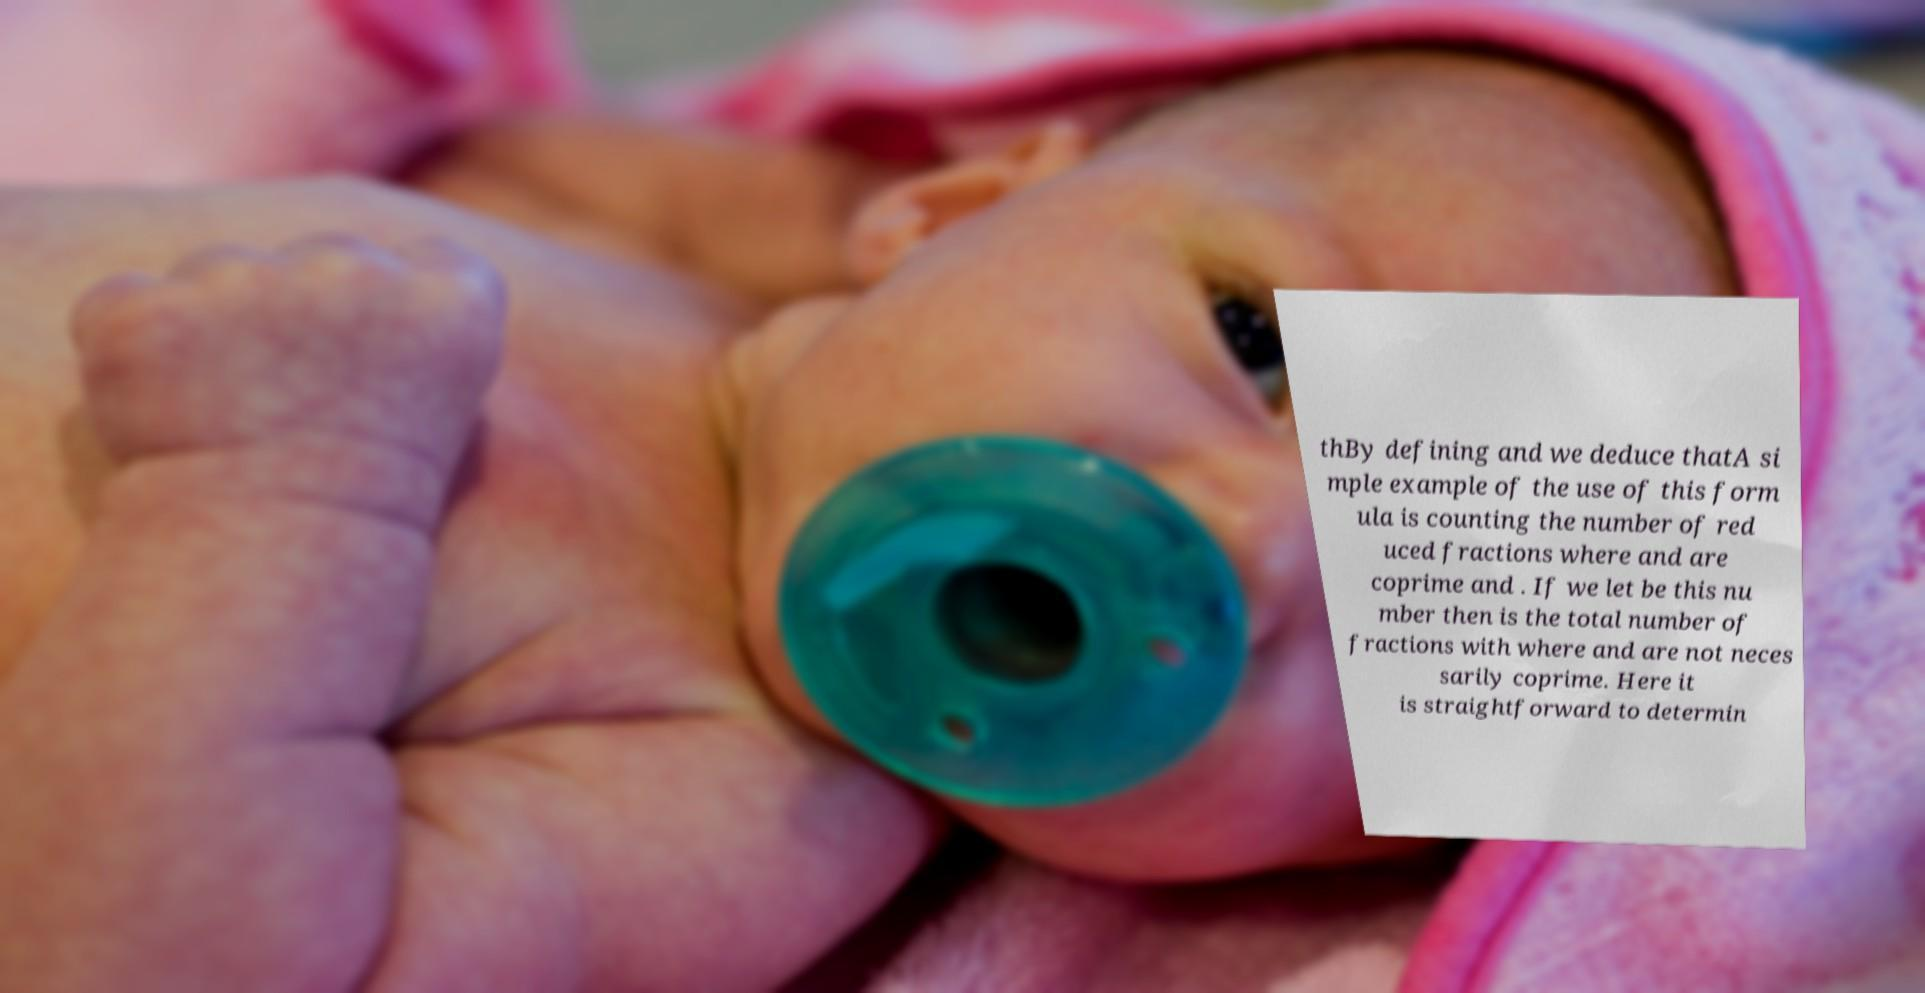Could you assist in decoding the text presented in this image and type it out clearly? thBy defining and we deduce thatA si mple example of the use of this form ula is counting the number of red uced fractions where and are coprime and . If we let be this nu mber then is the total number of fractions with where and are not neces sarily coprime. Here it is straightforward to determin 